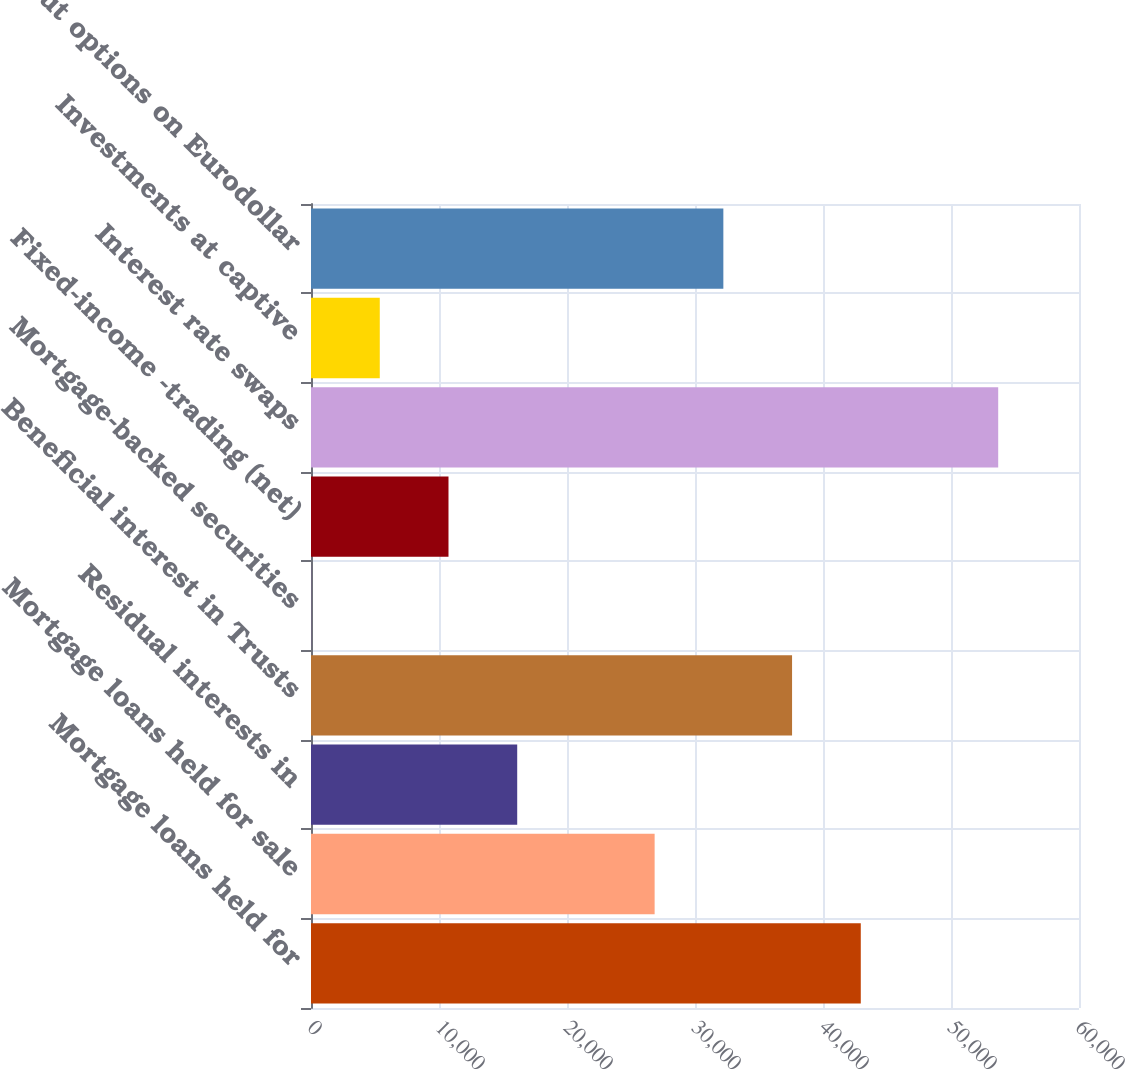<chart> <loc_0><loc_0><loc_500><loc_500><bar_chart><fcel>Mortgage loans held for<fcel>Mortgage loans held for sale<fcel>Residual interests in<fcel>Beneficial interest in Trusts<fcel>Mortgage-backed securities<fcel>Fixed-income -trading (net)<fcel>Interest rate swaps<fcel>Investments at captive<fcel>Put options on Eurodollar<nl><fcel>42951.4<fcel>26846.5<fcel>16109.9<fcel>37583.1<fcel>5<fcel>10741.6<fcel>53688<fcel>5373.3<fcel>32214.8<nl></chart> 